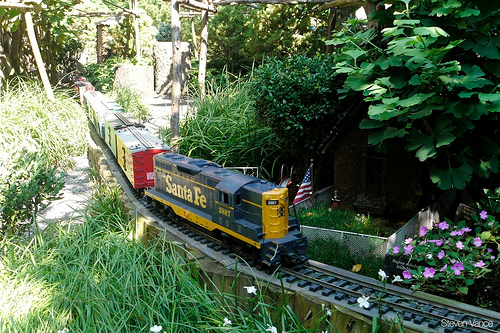Please provide the bounding box coordinate of the region this sentence describes: bush is a bright green color. The bright green bush is located within the bounding box coordinates [0.66, 0.17, 1.0, 0.55]. 